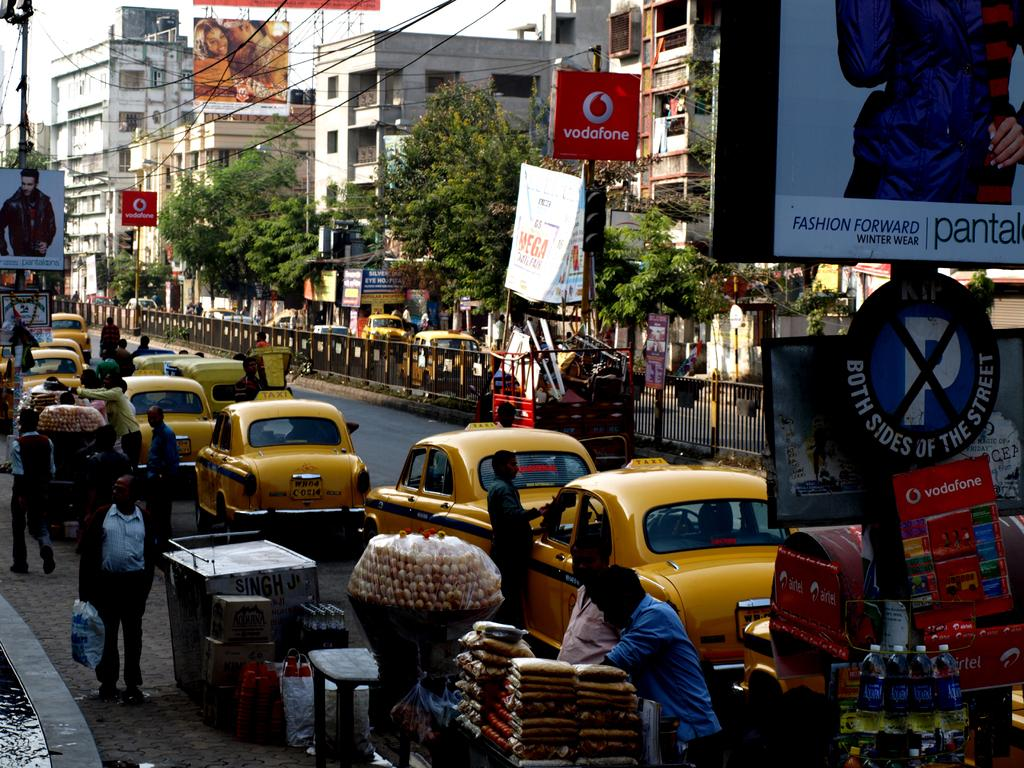Provide a one-sentence caption for the provided image. A busy street with a lot of taxis and a billboard sign saying Fashion Forward. 